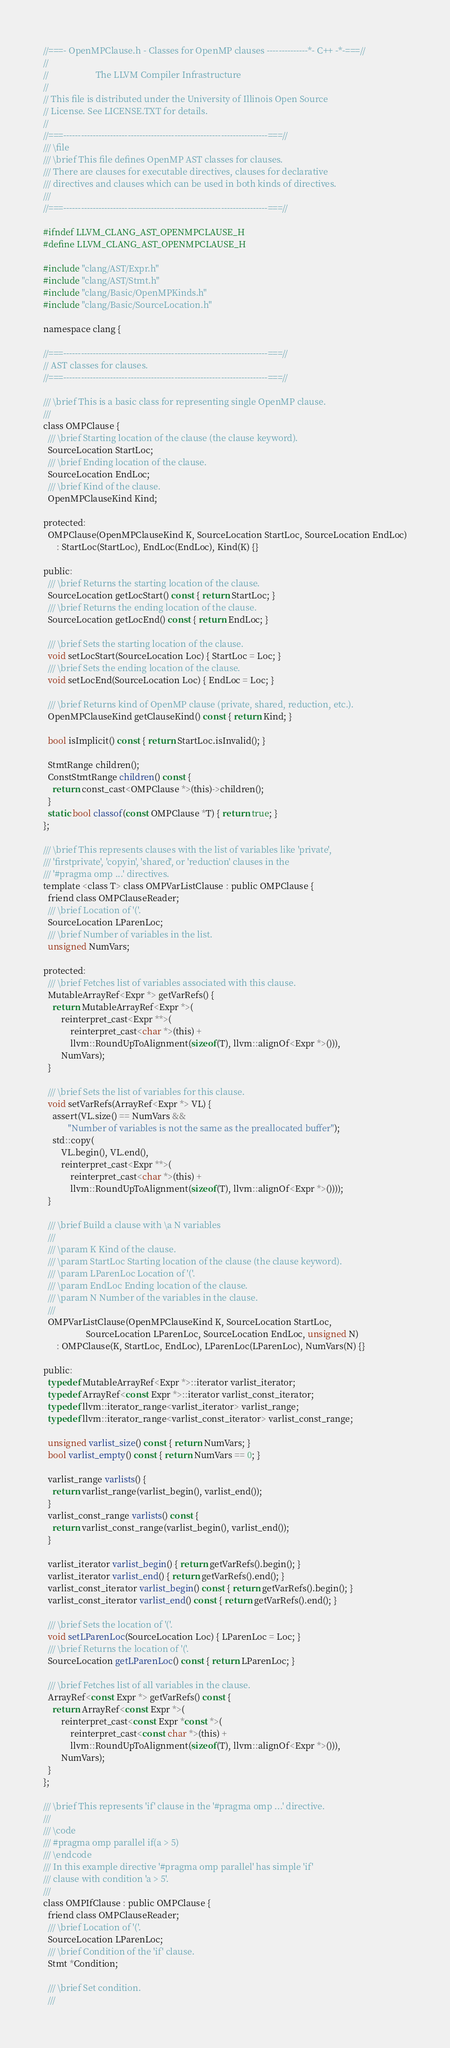Convert code to text. <code><loc_0><loc_0><loc_500><loc_500><_C_>//===- OpenMPClause.h - Classes for OpenMP clauses --------------*- C++ -*-===//
//
//                     The LLVM Compiler Infrastructure
//
// This file is distributed under the University of Illinois Open Source
// License. See LICENSE.TXT for details.
//
//===----------------------------------------------------------------------===//
/// \file
/// \brief This file defines OpenMP AST classes for clauses.
/// There are clauses for executable directives, clauses for declarative
/// directives and clauses which can be used in both kinds of directives.
///
//===----------------------------------------------------------------------===//

#ifndef LLVM_CLANG_AST_OPENMPCLAUSE_H
#define LLVM_CLANG_AST_OPENMPCLAUSE_H

#include "clang/AST/Expr.h"
#include "clang/AST/Stmt.h"
#include "clang/Basic/OpenMPKinds.h"
#include "clang/Basic/SourceLocation.h"

namespace clang {

//===----------------------------------------------------------------------===//
// AST classes for clauses.
//===----------------------------------------------------------------------===//

/// \brief This is a basic class for representing single OpenMP clause.
///
class OMPClause {
  /// \brief Starting location of the clause (the clause keyword).
  SourceLocation StartLoc;
  /// \brief Ending location of the clause.
  SourceLocation EndLoc;
  /// \brief Kind of the clause.
  OpenMPClauseKind Kind;

protected:
  OMPClause(OpenMPClauseKind K, SourceLocation StartLoc, SourceLocation EndLoc)
      : StartLoc(StartLoc), EndLoc(EndLoc), Kind(K) {}

public:
  /// \brief Returns the starting location of the clause.
  SourceLocation getLocStart() const { return StartLoc; }
  /// \brief Returns the ending location of the clause.
  SourceLocation getLocEnd() const { return EndLoc; }

  /// \brief Sets the starting location of the clause.
  void setLocStart(SourceLocation Loc) { StartLoc = Loc; }
  /// \brief Sets the ending location of the clause.
  void setLocEnd(SourceLocation Loc) { EndLoc = Loc; }

  /// \brief Returns kind of OpenMP clause (private, shared, reduction, etc.).
  OpenMPClauseKind getClauseKind() const { return Kind; }

  bool isImplicit() const { return StartLoc.isInvalid(); }

  StmtRange children();
  ConstStmtRange children() const {
    return const_cast<OMPClause *>(this)->children();
  }
  static bool classof(const OMPClause *T) { return true; }
};

/// \brief This represents clauses with the list of variables like 'private',
/// 'firstprivate', 'copyin', 'shared', or 'reduction' clauses in the
/// '#pragma omp ...' directives.
template <class T> class OMPVarListClause : public OMPClause {
  friend class OMPClauseReader;
  /// \brief Location of '('.
  SourceLocation LParenLoc;
  /// \brief Number of variables in the list.
  unsigned NumVars;

protected:
  /// \brief Fetches list of variables associated with this clause.
  MutableArrayRef<Expr *> getVarRefs() {
    return MutableArrayRef<Expr *>(
        reinterpret_cast<Expr **>(
            reinterpret_cast<char *>(this) +
            llvm::RoundUpToAlignment(sizeof(T), llvm::alignOf<Expr *>())),
        NumVars);
  }

  /// \brief Sets the list of variables for this clause.
  void setVarRefs(ArrayRef<Expr *> VL) {
    assert(VL.size() == NumVars &&
           "Number of variables is not the same as the preallocated buffer");
    std::copy(
        VL.begin(), VL.end(),
        reinterpret_cast<Expr **>(
            reinterpret_cast<char *>(this) +
            llvm::RoundUpToAlignment(sizeof(T), llvm::alignOf<Expr *>())));
  }

  /// \brief Build a clause with \a N variables
  ///
  /// \param K Kind of the clause.
  /// \param StartLoc Starting location of the clause (the clause keyword).
  /// \param LParenLoc Location of '('.
  /// \param EndLoc Ending location of the clause.
  /// \param N Number of the variables in the clause.
  ///
  OMPVarListClause(OpenMPClauseKind K, SourceLocation StartLoc,
                   SourceLocation LParenLoc, SourceLocation EndLoc, unsigned N)
      : OMPClause(K, StartLoc, EndLoc), LParenLoc(LParenLoc), NumVars(N) {}

public:
  typedef MutableArrayRef<Expr *>::iterator varlist_iterator;
  typedef ArrayRef<const Expr *>::iterator varlist_const_iterator;
  typedef llvm::iterator_range<varlist_iterator> varlist_range;
  typedef llvm::iterator_range<varlist_const_iterator> varlist_const_range;

  unsigned varlist_size() const { return NumVars; }
  bool varlist_empty() const { return NumVars == 0; }

  varlist_range varlists() {
    return varlist_range(varlist_begin(), varlist_end());
  }
  varlist_const_range varlists() const {
    return varlist_const_range(varlist_begin(), varlist_end());
  }

  varlist_iterator varlist_begin() { return getVarRefs().begin(); }
  varlist_iterator varlist_end() { return getVarRefs().end(); }
  varlist_const_iterator varlist_begin() const { return getVarRefs().begin(); }
  varlist_const_iterator varlist_end() const { return getVarRefs().end(); }

  /// \brief Sets the location of '('.
  void setLParenLoc(SourceLocation Loc) { LParenLoc = Loc; }
  /// \brief Returns the location of '('.
  SourceLocation getLParenLoc() const { return LParenLoc; }

  /// \brief Fetches list of all variables in the clause.
  ArrayRef<const Expr *> getVarRefs() const {
    return ArrayRef<const Expr *>(
        reinterpret_cast<const Expr *const *>(
            reinterpret_cast<const char *>(this) +
            llvm::RoundUpToAlignment(sizeof(T), llvm::alignOf<Expr *>())),
        NumVars);
  }
};

/// \brief This represents 'if' clause in the '#pragma omp ...' directive.
///
/// \code
/// #pragma omp parallel if(a > 5)
/// \endcode
/// In this example directive '#pragma omp parallel' has simple 'if'
/// clause with condition 'a > 5'.
///
class OMPIfClause : public OMPClause {
  friend class OMPClauseReader;
  /// \brief Location of '('.
  SourceLocation LParenLoc;
  /// \brief Condition of the 'if' clause.
  Stmt *Condition;

  /// \brief Set condition.
  ///</code> 